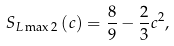Convert formula to latex. <formula><loc_0><loc_0><loc_500><loc_500>S _ { L \max 2 } \left ( c \right ) = \frac { 8 } { 9 } - \frac { 2 } { 3 } c ^ { 2 } ,</formula> 